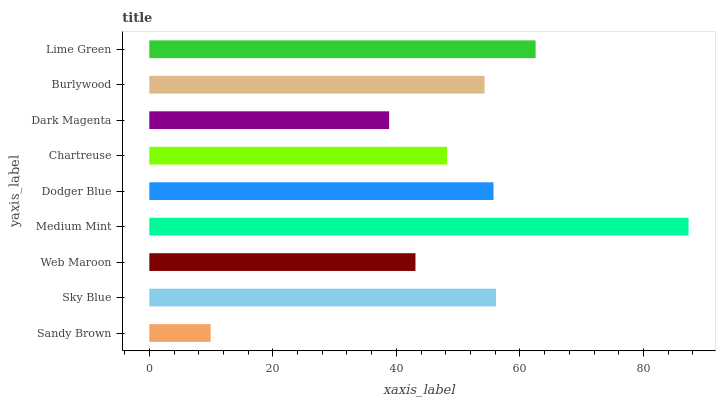Is Sandy Brown the minimum?
Answer yes or no. Yes. Is Medium Mint the maximum?
Answer yes or no. Yes. Is Sky Blue the minimum?
Answer yes or no. No. Is Sky Blue the maximum?
Answer yes or no. No. Is Sky Blue greater than Sandy Brown?
Answer yes or no. Yes. Is Sandy Brown less than Sky Blue?
Answer yes or no. Yes. Is Sandy Brown greater than Sky Blue?
Answer yes or no. No. Is Sky Blue less than Sandy Brown?
Answer yes or no. No. Is Burlywood the high median?
Answer yes or no. Yes. Is Burlywood the low median?
Answer yes or no. Yes. Is Sky Blue the high median?
Answer yes or no. No. Is Sandy Brown the low median?
Answer yes or no. No. 